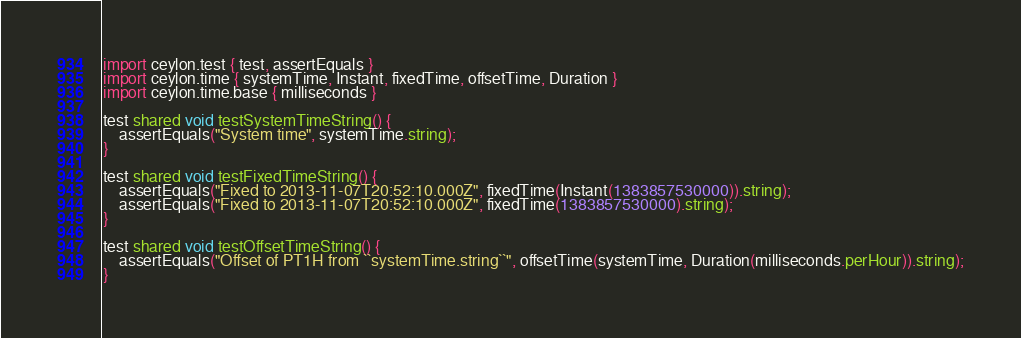Convert code to text. <code><loc_0><loc_0><loc_500><loc_500><_Ceylon_>import ceylon.test { test, assertEquals }
import ceylon.time { systemTime, Instant, fixedTime, offsetTime, Duration }
import ceylon.time.base { milliseconds }

test shared void testSystemTimeString() {
    assertEquals("System time", systemTime.string);
}

test shared void testFixedTimeString() {
    assertEquals("Fixed to 2013-11-07T20:52:10.000Z", fixedTime(Instant(1383857530000)).string);
    assertEquals("Fixed to 2013-11-07T20:52:10.000Z", fixedTime(1383857530000).string);
}

test shared void testOffsetTimeString() {
    assertEquals("Offset of PT1H from ``systemTime.string``", offsetTime(systemTime, Duration(milliseconds.perHour)).string);
}
</code> 